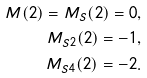<formula> <loc_0><loc_0><loc_500><loc_500>M ( 2 ) = M _ { S } ( 2 ) = 0 , \\ M _ { S 2 } ( 2 ) = - 1 , \\ M _ { S 4 } ( 2 ) = - 2 .</formula> 